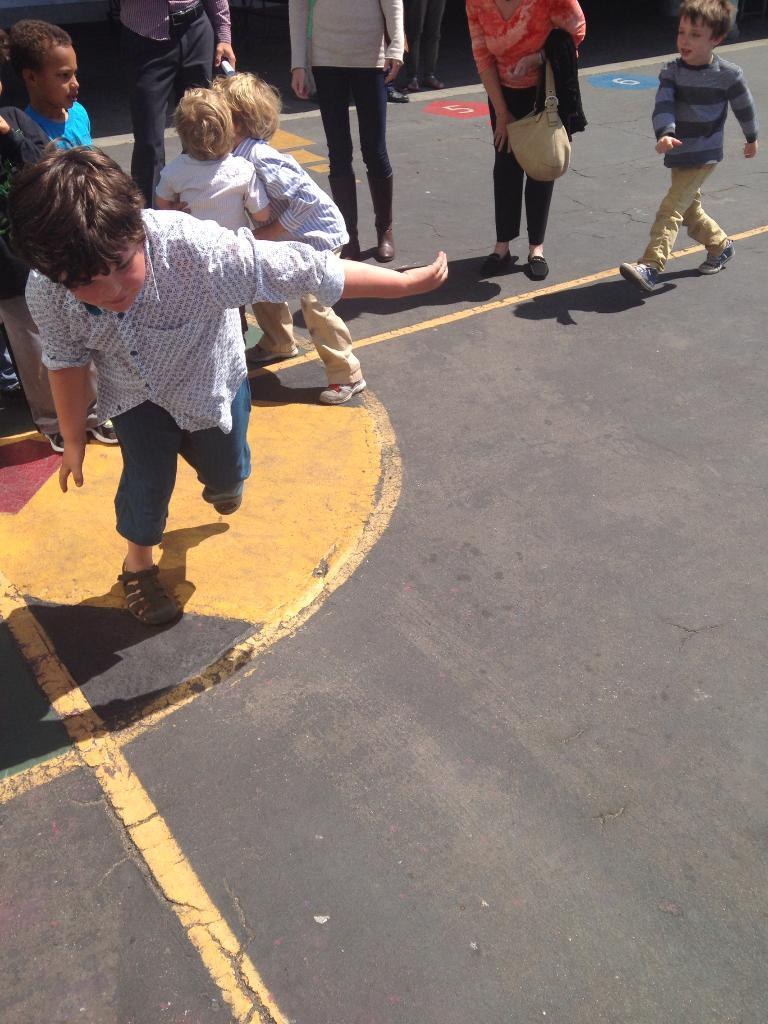Who is present in the image? There are persons and kids in the image. What are the persons and kids wearing? The persons and kids are wearing clothes. Where is the sink located in the image? There is no sink present in the image. What type of exchange is happening between the persons and kids in the image? The image does not depict any exchange between the persons and kids. 